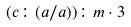<formula> <loc_0><loc_0><loc_500><loc_500>( c \colon ( a / a ) ) \colon m \cdot 3</formula> 